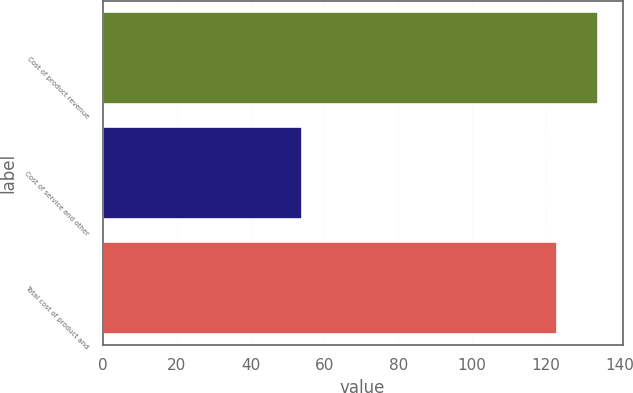Convert chart to OTSL. <chart><loc_0><loc_0><loc_500><loc_500><bar_chart><fcel>Cost of product revenue<fcel>Cost of service and other<fcel>Total cost of product and<nl><fcel>134<fcel>54<fcel>123<nl></chart> 